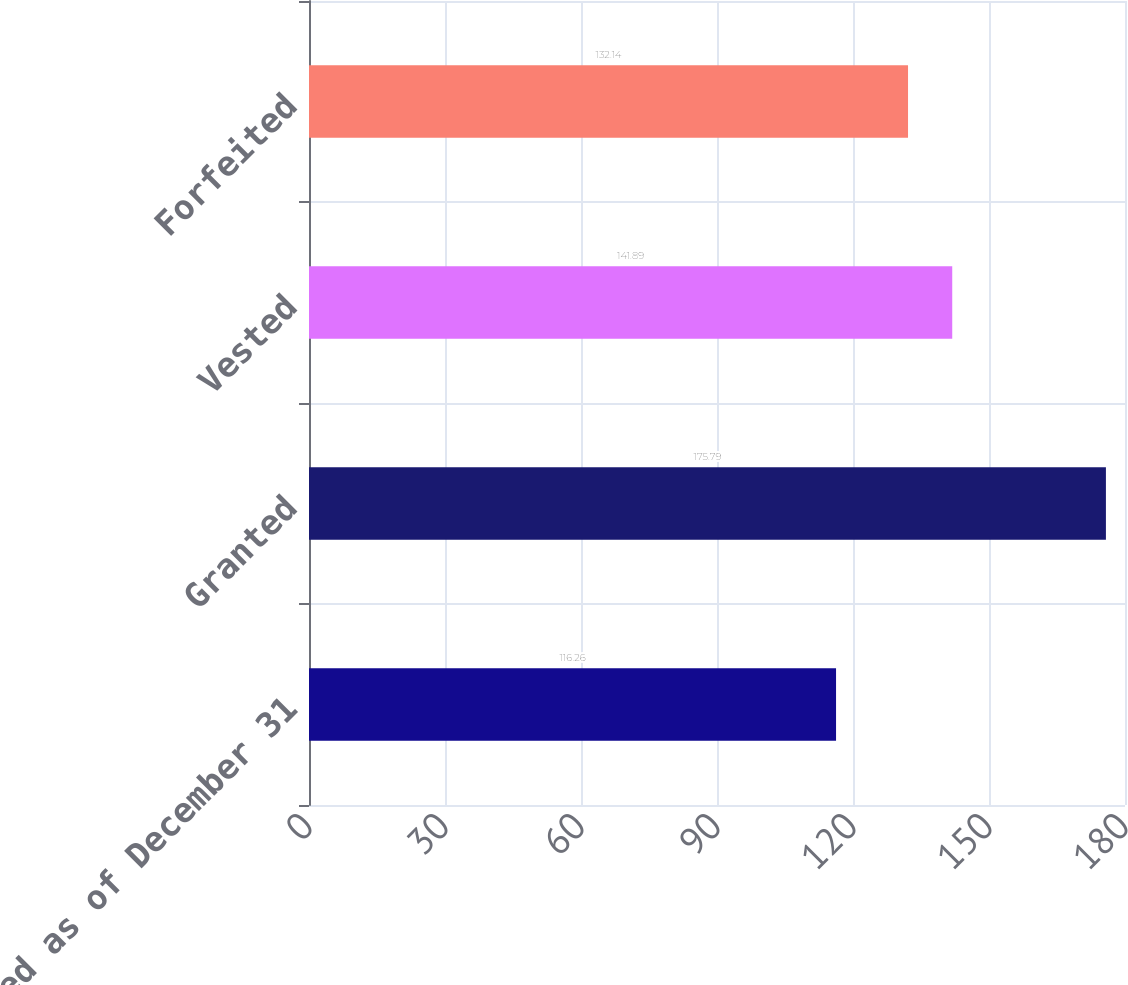Convert chart. <chart><loc_0><loc_0><loc_500><loc_500><bar_chart><fcel>Nonvested as of December 31<fcel>Granted<fcel>Vested<fcel>Forfeited<nl><fcel>116.26<fcel>175.79<fcel>141.89<fcel>132.14<nl></chart> 